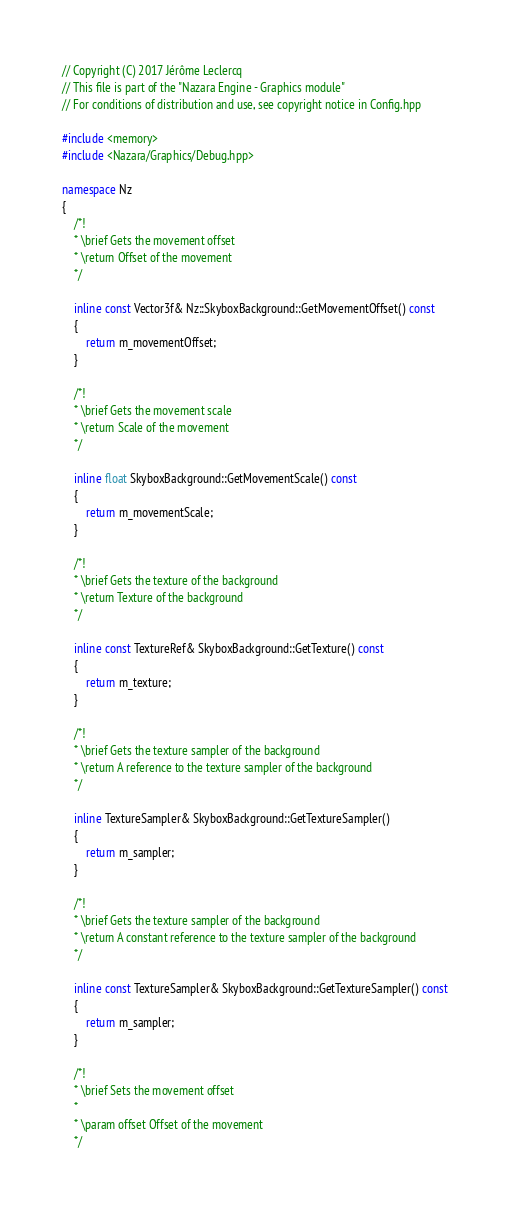Convert code to text. <code><loc_0><loc_0><loc_500><loc_500><_C++_>// Copyright (C) 2017 Jérôme Leclercq
// This file is part of the "Nazara Engine - Graphics module"
// For conditions of distribution and use, see copyright notice in Config.hpp

#include <memory>
#include <Nazara/Graphics/Debug.hpp>

namespace Nz
{
	/*!
	* \brief Gets the movement offset
	* \return Offset of the movement
	*/

	inline const Vector3f& Nz::SkyboxBackground::GetMovementOffset() const
	{
		return m_movementOffset;
	}

	/*!
	* \brief Gets the movement scale
	* \return Scale of the movement
	*/

	inline float SkyboxBackground::GetMovementScale() const
	{
		return m_movementScale;
	}

	/*!
	* \brief Gets the texture of the background
	* \return Texture of the background
	*/

	inline const TextureRef& SkyboxBackground::GetTexture() const
	{
		return m_texture;
	}

	/*!
	* \brief Gets the texture sampler of the background
	* \return A reference to the texture sampler of the background
	*/

	inline TextureSampler& SkyboxBackground::GetTextureSampler()
	{
		return m_sampler;
	}

	/*!
	* \brief Gets the texture sampler of the background
	* \return A constant reference to the texture sampler of the background
	*/

	inline const TextureSampler& SkyboxBackground::GetTextureSampler() const
	{
		return m_sampler;
	}

	/*!
	* \brief Sets the movement offset
	*
	* \param offset Offset of the movement
	*/
</code> 